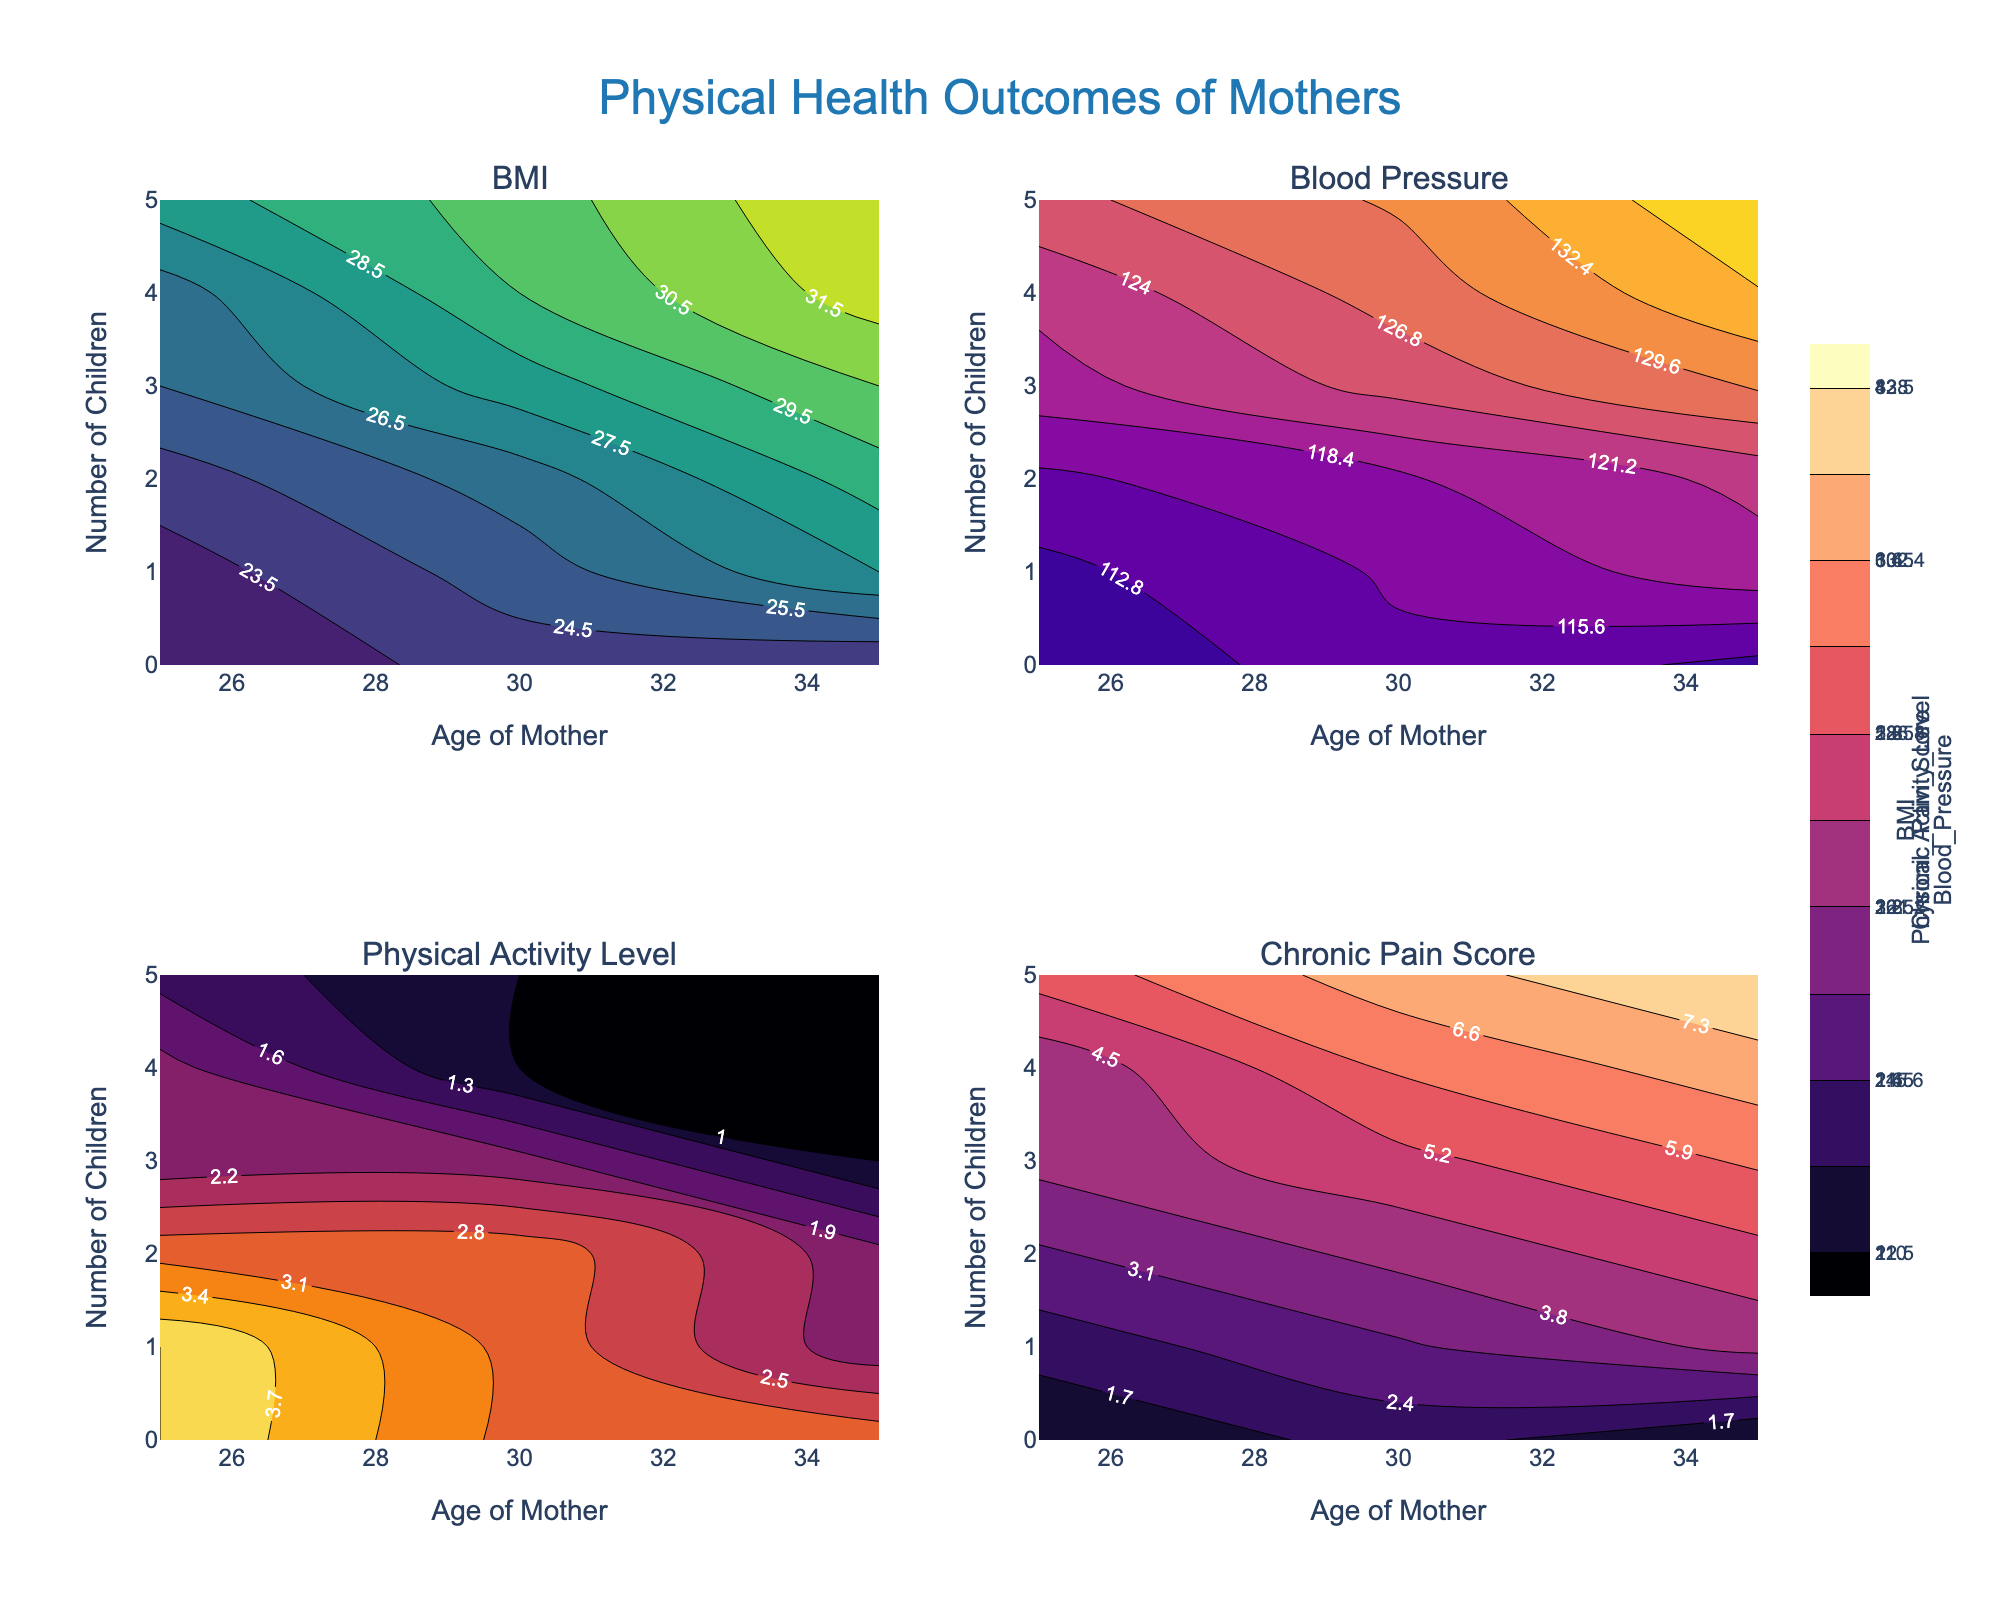How does the BMI change with the number of children for mothers aged 35? The contour plot of BMI will show trends; as the mother's age is fixed at 35, the BMI values can be traced along the increasing number of children. The plot suggests that BMI increases with the number of children among mothers aged 35, with values moving from approximately 23.5 to 32.5.
Answer: BMI increases with more children At what age does the contour plot of Physical Activity Level start showing significant changes as the number of children increases from 0 to 4? By examining the contour plot for Physical Activity Level, observe the age where changes in contour lines become more prominent as the number of children increases. Significant changes start appearing around the age of 30.
Answer: Around age 30 Which variable shows the greatest variation in mothers aged 25 with 0 to 4 children? Check each subplot for mothers aged 25 and notice the range of values for BMI, Blood Pressure, Physical Activity Level, and Chronic Pain Score. The subplot for BMI shows the greatest variation in this age group.
Answer: BMI Is there a trend in Chronic Pain Score for mothers aged 30 as the number of children increases? Look at the contour plot for Chronic Pain Score and observe the trend for mothers aged 30. The contour lines show an increasing trend in Chronic Pain Score as the number of children increases from 0 to 5.
Answer: Increasing trend How does blood pressure for mothers with three children change with age? Inspect the Blood Pressure contour plot and trace how the contour lines correspond to blood pressure levels for mothers with three children at different ages. The contours indicate that blood pressure increases with age.
Answer: Increases with age Compare the physical activity levels of mothers aged 25 with no children and those aged 35 with five children. Observe the contour plot for Physical Activity Level. For mothers aged 25 with no children, the Physical Activity Level is around 4. For mothers aged 35 with five children, it is around 1.
Answer: Higher at age 25 with no children At what number of children does the contour plot for BMI at age 30 show the steepest increase? Examine the BMI contour plot and identify the point where the contour lines are most spaced out for mothers aged 30. The steepest increase occurs between 3 and 4 children.
Answer: Between 3 and 4 children What can you infer about the trend in Physical Activity Level for mothers with 2 children as they age? Look at the Physical Activity Level plot and follow the contour lines for mothers with 2 children as the age varies from 25 to 35. The trend shows a slight decrease in Physical Activity Level with aging.
Answer: Slight decrease Which variable shows the most significant change for mothers aged 35 from having no children to having five children? Compare the subplots and observe the range shift in values for mothers aged 35 from having no children to having five. The Chronic Pain Score shows the most significant change.
Answer: Chronic Pain Score Is there any variable that remains relatively constant regardless of the number of children, specifically for mothers aged 25? Inspect the contour plots for each variable for mothers aged 25 across different numbers of children. The Physical Activity Level appears to remain relatively constant.
Answer: Physical Activity Level 